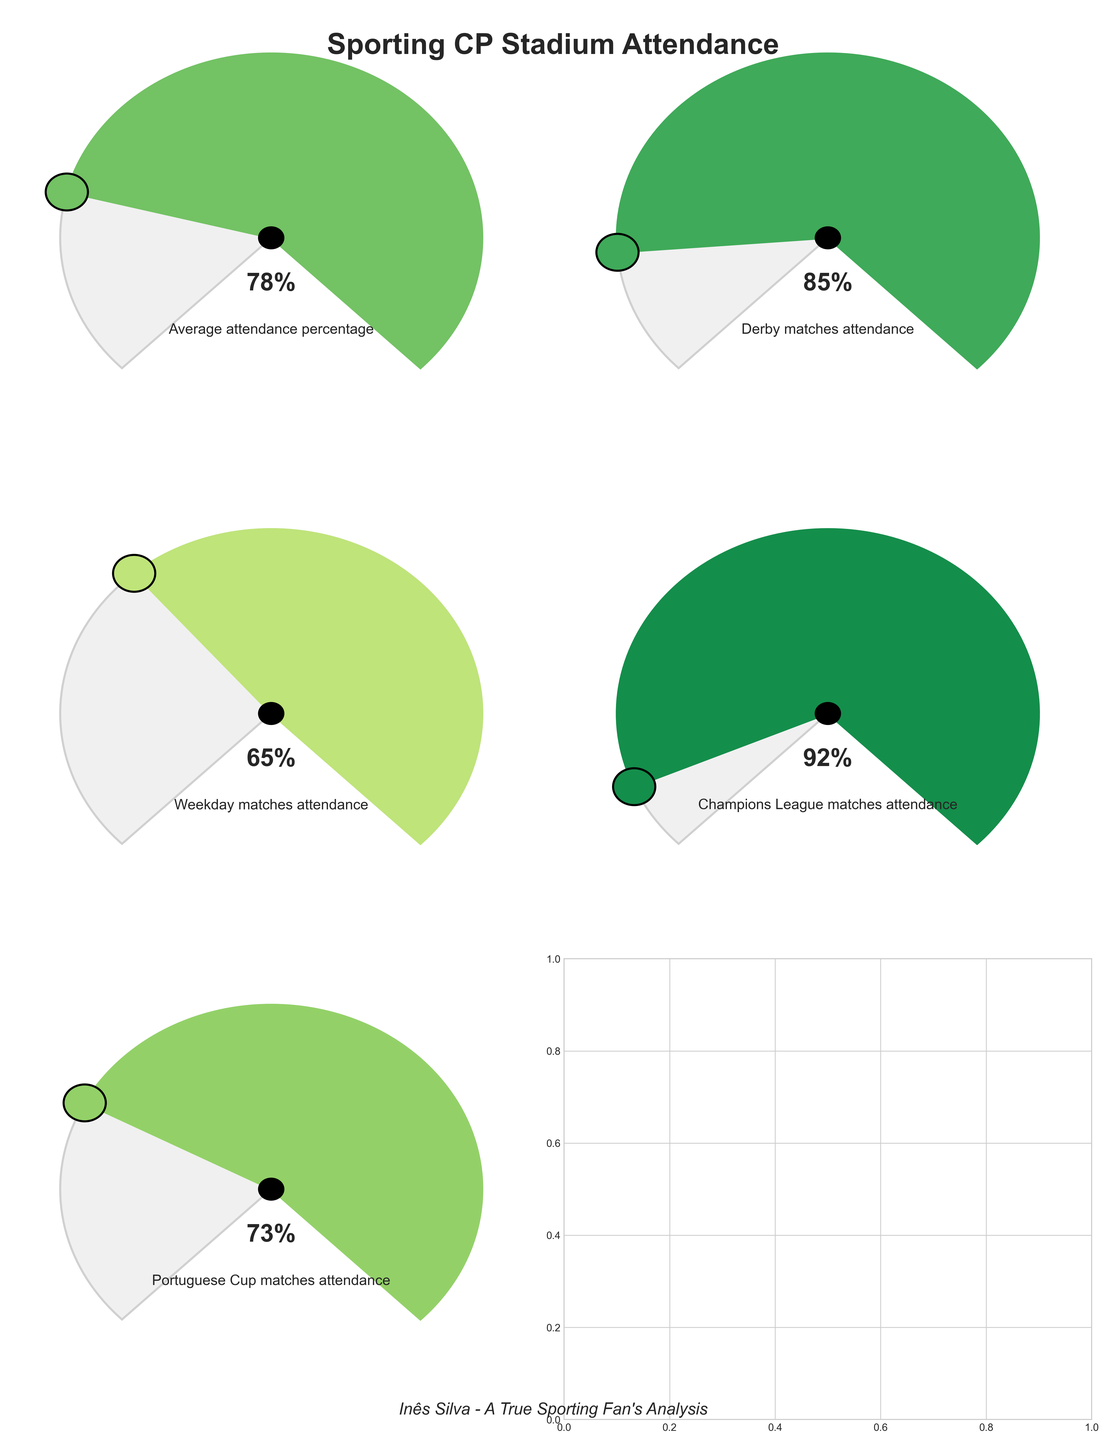What's the average attendance percentage at Sporting CP stadium? Check the gauge labeled 'Average attendance percentage'. It indicates 78%.
Answer: 78% Which type of match has the highest attendance percentage? Among the gauges, the one labeled 'Champions League matches attendance' shows the highest percentage at 92%.
Answer: Champions League matches What's the attendance percentage difference between Derby matches and Weekday matches? Derby matches have an attendance percentage of 85% and Weekday matches have 65%. The difference is 85% - 65% = 20%.
Answer: 20% How does the attendance for Portuguese Cup matches compare to the average attendance percentage? Portuguese Cup matches have an attendance percentage of 73%, while the average attendance percentage is 78%. Thus, the Portuguese Cup matches have a 5% lower attendance than the average.
Answer: 5% lower What is the median attendance percentage among the given match types? List the attendance percentages: 78%, 85%, 65%, 92%, 73%. Arrange in ascending order: 65%, 73%, 78%, 85%, 92%. The median is the middle value, which is 78%.
Answer: 78% What's the overall range of attendance percentages observed? The highest percentage is 92% (Champions League matches) and the lowest is 65% (Weekday matches). The range is 92% - 65% = 27%.
Answer: 27% Which match type has attendance closest to the average attendance percentage? The average attendance percentage is 78%. Compare other values: Derby is 85%, Weekday is 65%, Champions League is 92%, Portuguese Cup is 73%. Portuguese Cup matches are just 5% away from the average (78% - 73%).
Answer: Portuguese Cup matches What's the second highest attendance percentage among the match types? Highest is 92% (Champions League). The second highest is 85% (Derby matches).
Answer: 85% 